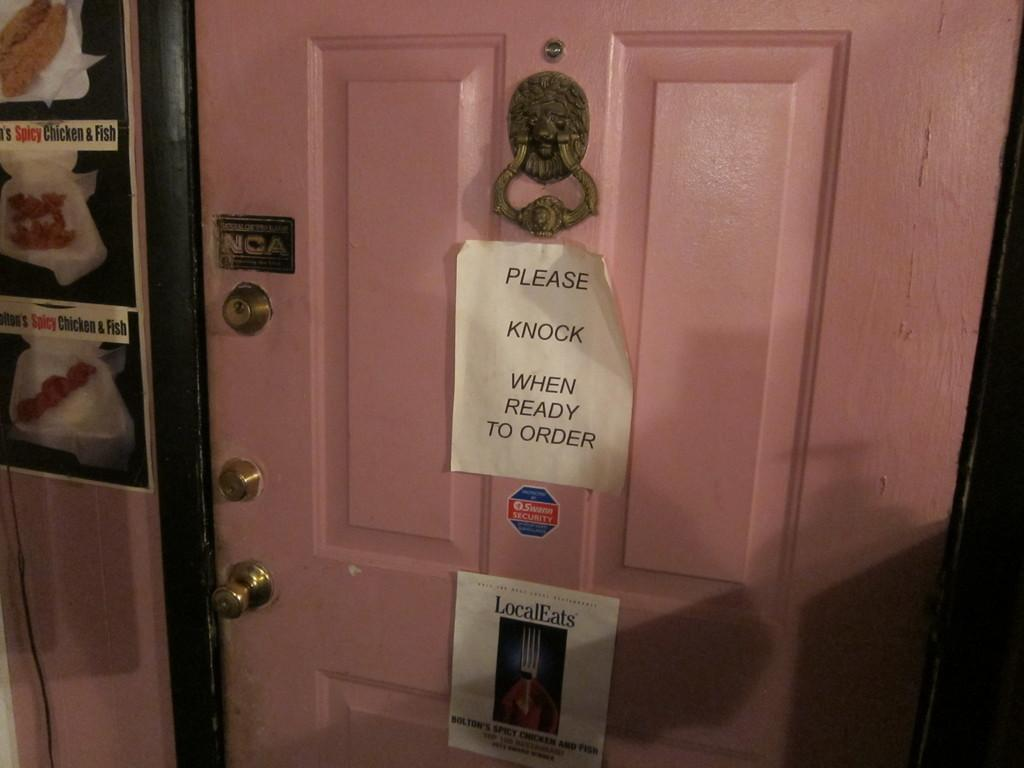Provide a one-sentence caption for the provided image. A door has a please knock when ready to order sign on it. 